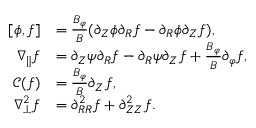<formula> <loc_0><loc_0><loc_500><loc_500>\begin{array} { r l } { [ \phi , f ] } & { = \frac { B _ { \varphi } } { B } ( \partial _ { Z } \phi \partial _ { R } f - \partial _ { R } \phi \partial _ { Z } f ) , } \\ { \nabla _ { \| } f } & { = \partial _ { Z } \psi \partial _ { R } f - \partial _ { R } \psi \partial _ { Z } f + \frac { B _ { \varphi } } { B } \partial _ { \varphi } f , } \\ { \mathcal { C } ( f ) } & { = \frac { B _ { \varphi } } { B } \partial _ { Z } f , } \\ { \nabla _ { \perp } ^ { 2 } f } & { = \partial _ { R R } ^ { 2 } f + \partial _ { Z Z } ^ { 2 } f . } \end{array}</formula> 